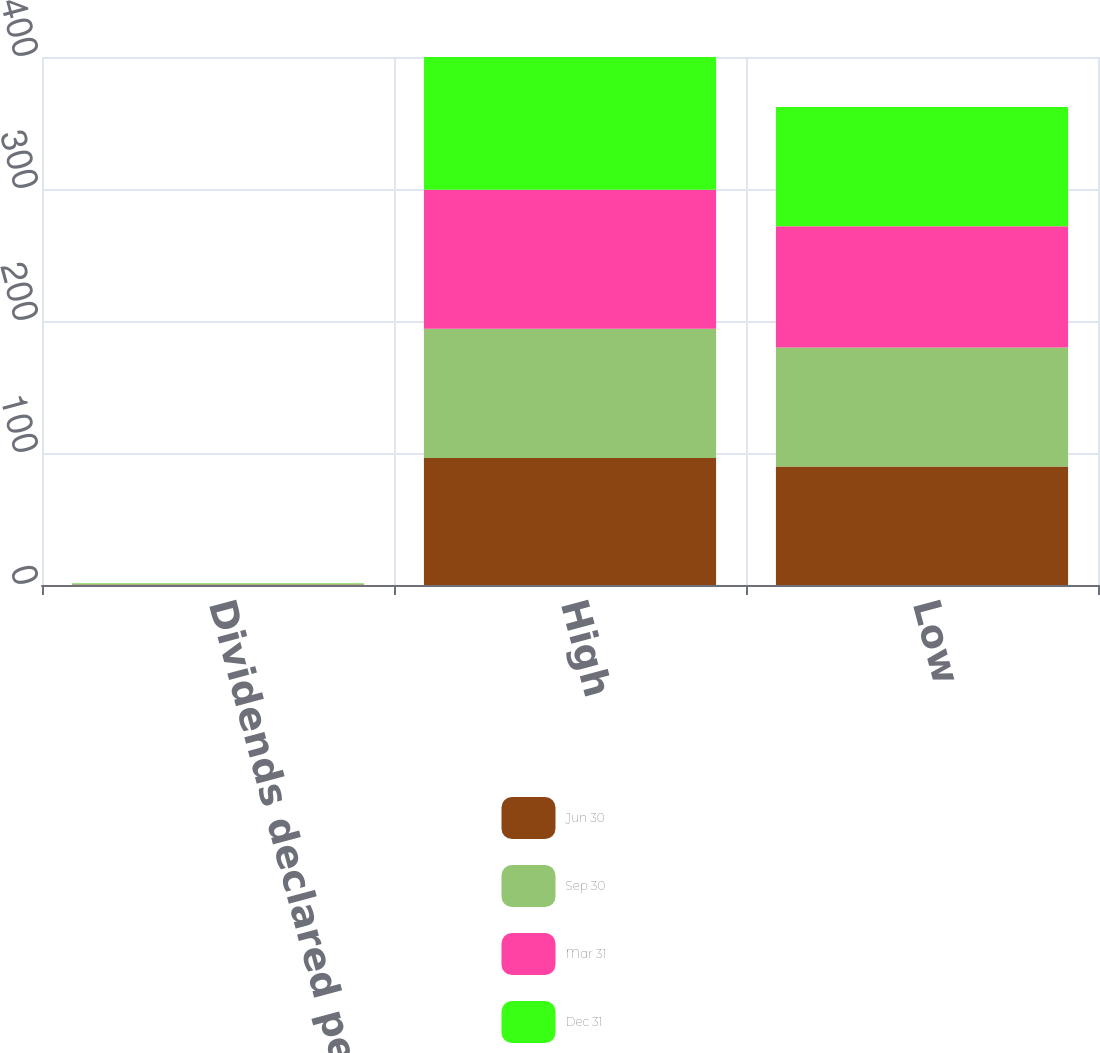Convert chart to OTSL. <chart><loc_0><loc_0><loc_500><loc_500><stacked_bar_chart><ecel><fcel>Dividends declared per share<fcel>High<fcel>Low<nl><fcel>Jun 30<fcel>0.34<fcel>96.18<fcel>89.81<nl><fcel>Sep 30<fcel>0.34<fcel>97.94<fcel>90.19<nl><fcel>Mar 31<fcel>0.34<fcel>105.34<fcel>91.73<nl><fcel>Dec 31<fcel>0.38<fcel>100.51<fcel>90.3<nl></chart> 